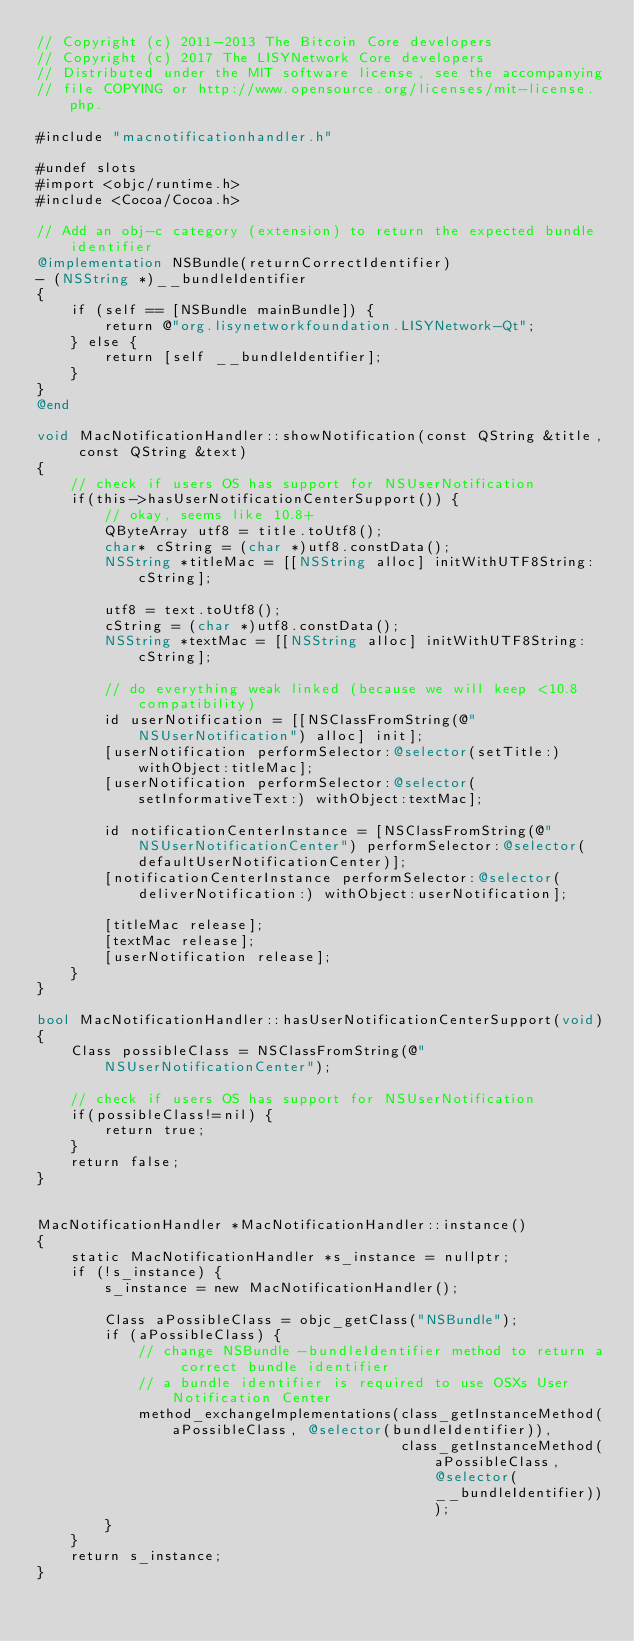<code> <loc_0><loc_0><loc_500><loc_500><_ObjectiveC_>// Copyright (c) 2011-2013 The Bitcoin Core developers
// Copyright (c) 2017 The LISYNetwork Core developers
// Distributed under the MIT software license, see the accompanying
// file COPYING or http://www.opensource.org/licenses/mit-license.php.

#include "macnotificationhandler.h"

#undef slots
#import <objc/runtime.h>
#include <Cocoa/Cocoa.h>

// Add an obj-c category (extension) to return the expected bundle identifier
@implementation NSBundle(returnCorrectIdentifier)
- (NSString *)__bundleIdentifier
{
    if (self == [NSBundle mainBundle]) {
        return @"org.lisynetworkfoundation.LISYNetwork-Qt";
    } else {
        return [self __bundleIdentifier];
    }
}
@end

void MacNotificationHandler::showNotification(const QString &title, const QString &text)
{
    // check if users OS has support for NSUserNotification
    if(this->hasUserNotificationCenterSupport()) {
        // okay, seems like 10.8+
        QByteArray utf8 = title.toUtf8();
        char* cString = (char *)utf8.constData();
        NSString *titleMac = [[NSString alloc] initWithUTF8String:cString];

        utf8 = text.toUtf8();
        cString = (char *)utf8.constData();
        NSString *textMac = [[NSString alloc] initWithUTF8String:cString];

        // do everything weak linked (because we will keep <10.8 compatibility)
        id userNotification = [[NSClassFromString(@"NSUserNotification") alloc] init];
        [userNotification performSelector:@selector(setTitle:) withObject:titleMac];
        [userNotification performSelector:@selector(setInformativeText:) withObject:textMac];

        id notificationCenterInstance = [NSClassFromString(@"NSUserNotificationCenter") performSelector:@selector(defaultUserNotificationCenter)];
        [notificationCenterInstance performSelector:@selector(deliverNotification:) withObject:userNotification];

        [titleMac release];
        [textMac release];
        [userNotification release];
    }
}

bool MacNotificationHandler::hasUserNotificationCenterSupport(void)
{
    Class possibleClass = NSClassFromString(@"NSUserNotificationCenter");

    // check if users OS has support for NSUserNotification
    if(possibleClass!=nil) {
        return true;
    }
    return false;
}


MacNotificationHandler *MacNotificationHandler::instance()
{
    static MacNotificationHandler *s_instance = nullptr;
    if (!s_instance) {
        s_instance = new MacNotificationHandler();
        
        Class aPossibleClass = objc_getClass("NSBundle");
        if (aPossibleClass) {
            // change NSBundle -bundleIdentifier method to return a correct bundle identifier
            // a bundle identifier is required to use OSXs User Notification Center
            method_exchangeImplementations(class_getInstanceMethod(aPossibleClass, @selector(bundleIdentifier)),
                                           class_getInstanceMethod(aPossibleClass, @selector(__bundleIdentifier)));
        }
    }
    return s_instance;
}
</code> 